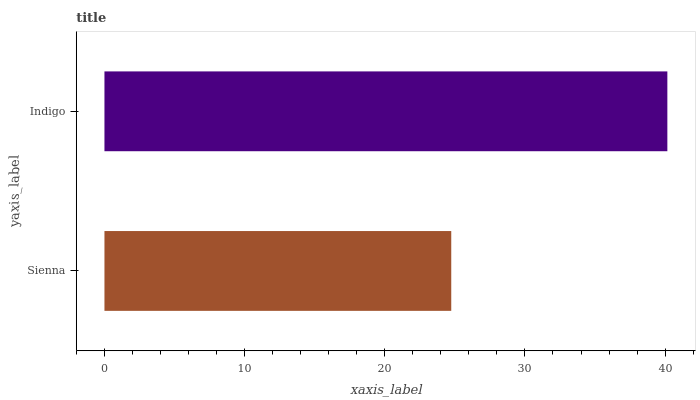Is Sienna the minimum?
Answer yes or no. Yes. Is Indigo the maximum?
Answer yes or no. Yes. Is Indigo the minimum?
Answer yes or no. No. Is Indigo greater than Sienna?
Answer yes or no. Yes. Is Sienna less than Indigo?
Answer yes or no. Yes. Is Sienna greater than Indigo?
Answer yes or no. No. Is Indigo less than Sienna?
Answer yes or no. No. Is Indigo the high median?
Answer yes or no. Yes. Is Sienna the low median?
Answer yes or no. Yes. Is Sienna the high median?
Answer yes or no. No. Is Indigo the low median?
Answer yes or no. No. 